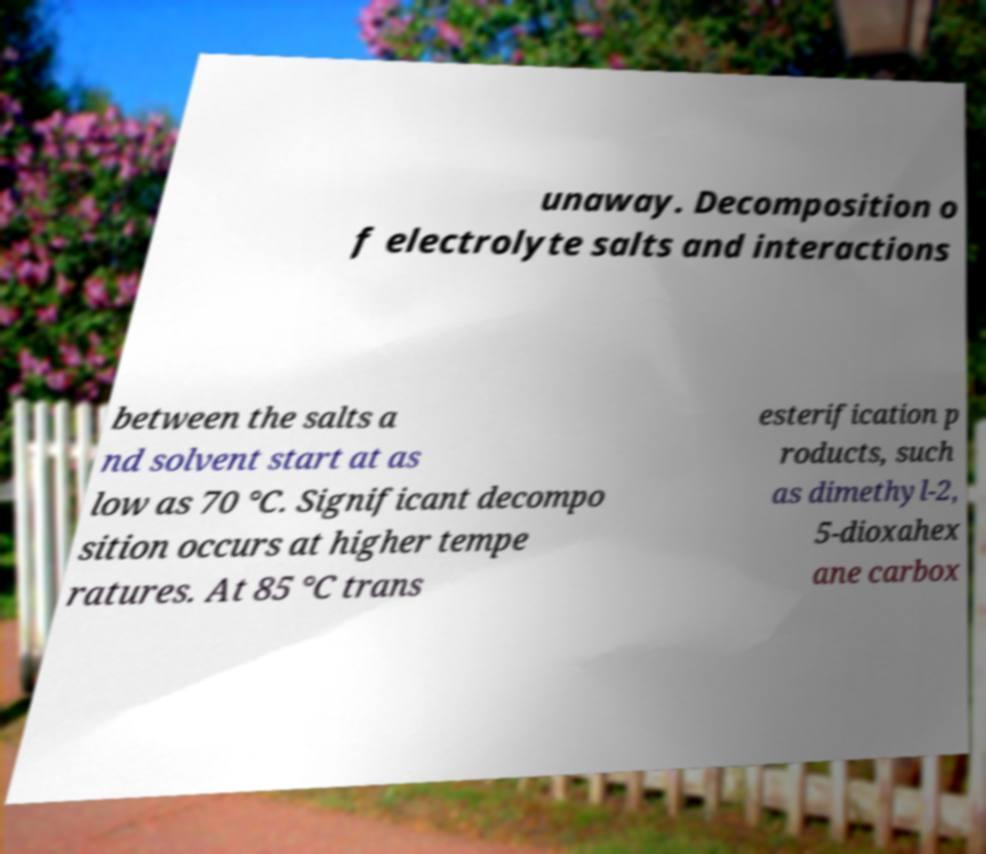For documentation purposes, I need the text within this image transcribed. Could you provide that? unaway. Decomposition o f electrolyte salts and interactions between the salts a nd solvent start at as low as 70 °C. Significant decompo sition occurs at higher tempe ratures. At 85 °C trans esterification p roducts, such as dimethyl-2, 5-dioxahex ane carbox 